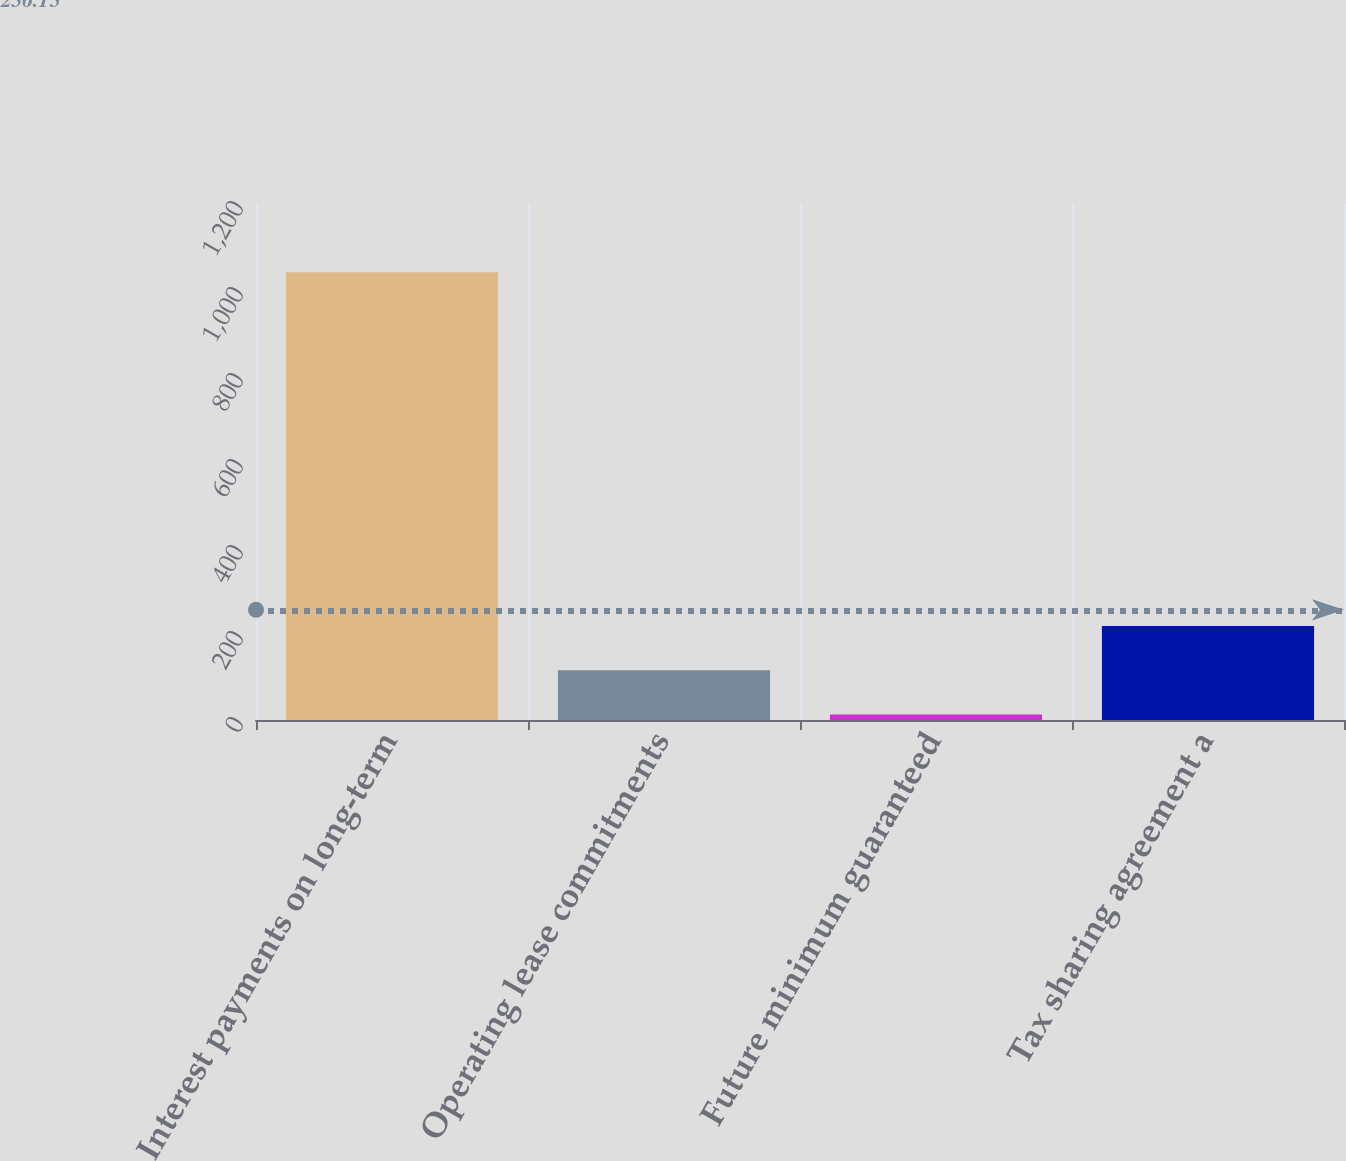Convert chart to OTSL. <chart><loc_0><loc_0><loc_500><loc_500><bar_chart><fcel>Interest payments on long-term<fcel>Operating lease commitments<fcel>Future minimum guaranteed<fcel>Tax sharing agreement a<nl><fcel>1041.4<fcel>115.84<fcel>13<fcel>218.68<nl></chart> 